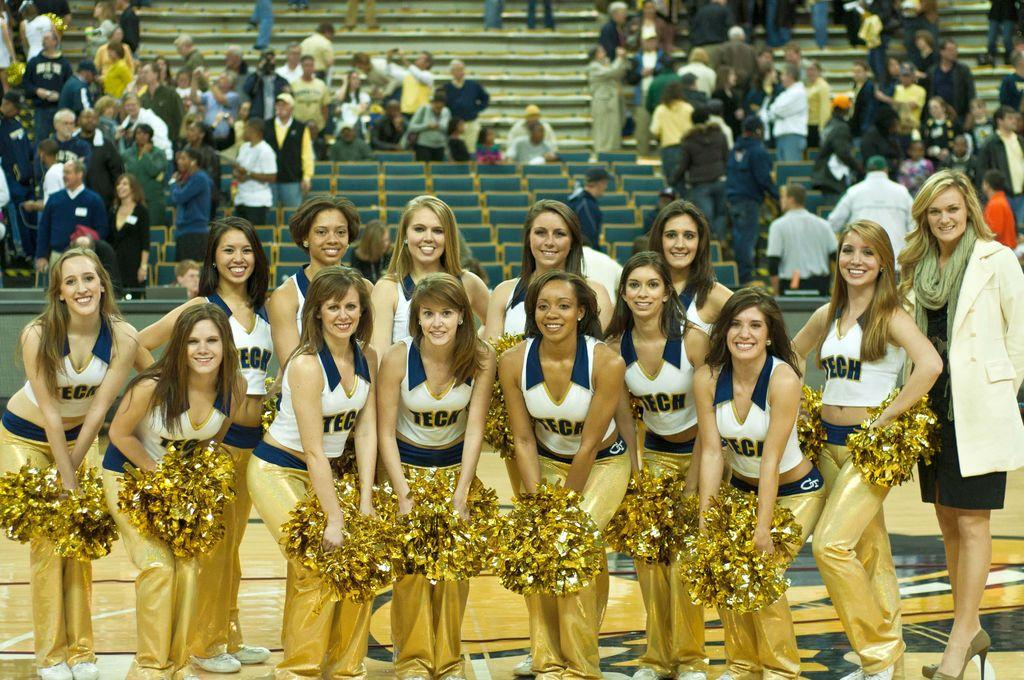<image>
Offer a succinct explanation of the picture presented. A group photo of female Tech cheerleaders posing in a gym. 